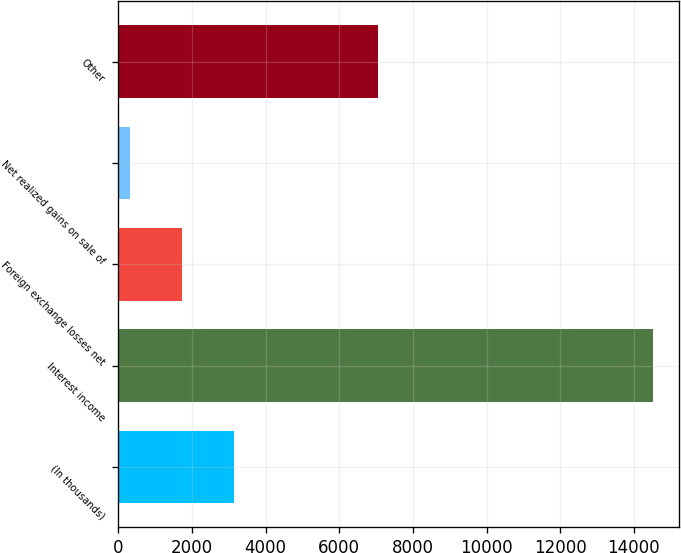Convert chart. <chart><loc_0><loc_0><loc_500><loc_500><bar_chart><fcel>(In thousands)<fcel>Interest income<fcel>Foreign exchange losses net<fcel>Net realized gains on sale of<fcel>Other<nl><fcel>3150.2<fcel>14507<fcel>1730.6<fcel>311<fcel>7051<nl></chart> 